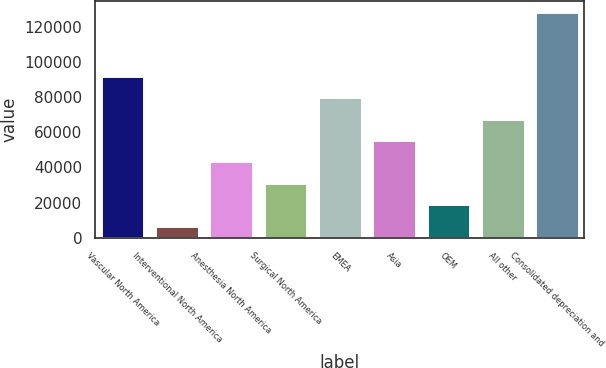<chart> <loc_0><loc_0><loc_500><loc_500><bar_chart><fcel>Vascular North America<fcel>Interventional North America<fcel>Anesthesia North America<fcel>Surgical North America<fcel>EMEA<fcel>Asia<fcel>OEM<fcel>All other<fcel>Consolidated depreciation and<nl><fcel>91940.1<fcel>6993<fcel>43398.9<fcel>31263.6<fcel>79804.8<fcel>55534.2<fcel>19128.3<fcel>67669.5<fcel>128346<nl></chart> 